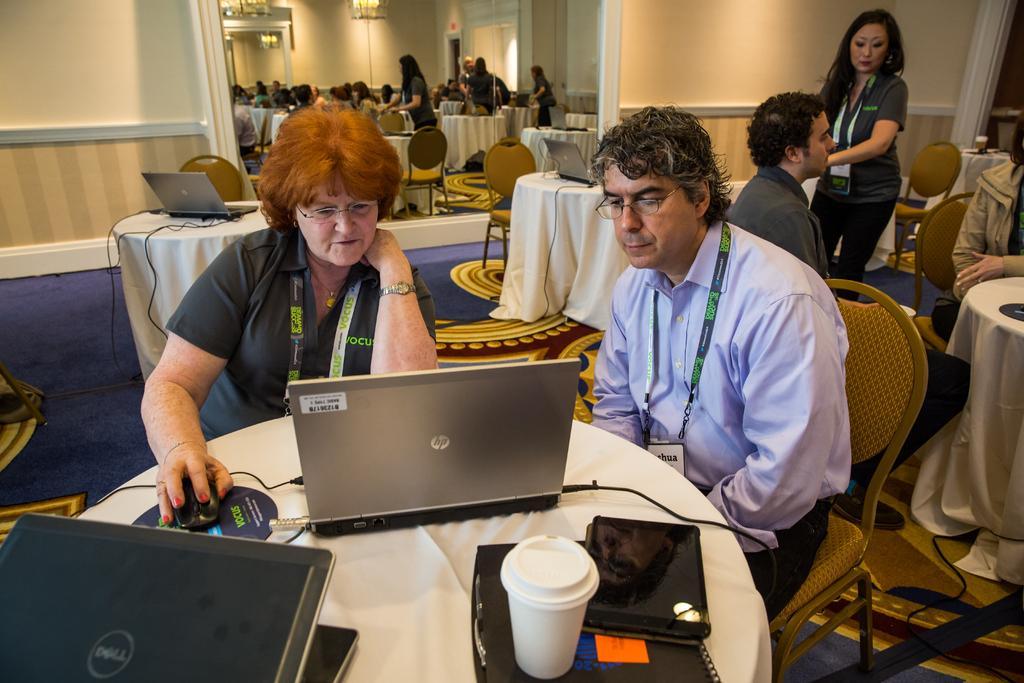Please provide a concise description of this image. There is a woman sitting on a chair holding a mouse, which is on the table, on which, there is a laptop, a book and glass on a file and another laptop and the table is covered with white color cloth. In the background, there is a mirror, near a wall and near a laptop on the table, which is covered with white color cloth. In the mirror, we can see, there are persons sitting on chairs around the table and some persons standing. 